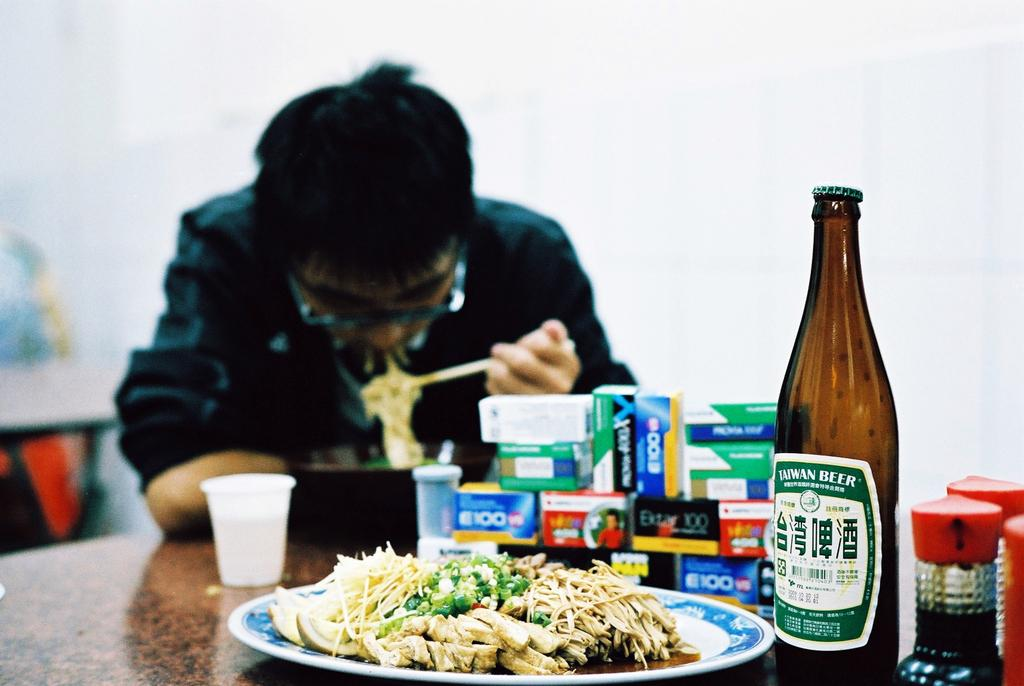Provide a one-sentence caption for the provided image. A person is sitting at a table eating noodles with a Taiwan Beer in the foreground. 